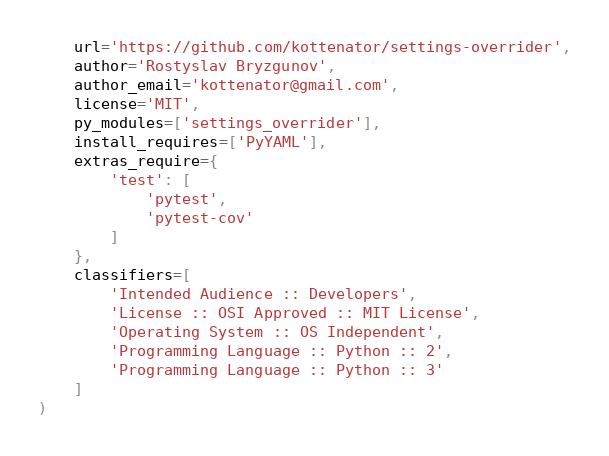Convert code to text. <code><loc_0><loc_0><loc_500><loc_500><_Python_>    url='https://github.com/kottenator/settings-overrider',
    author='Rostyslav Bryzgunov',
    author_email='kottenator@gmail.com',
    license='MIT',
    py_modules=['settings_overrider'],
    install_requires=['PyYAML'],
    extras_require={
        'test': [
            'pytest',
            'pytest-cov'
        ]
    },
    classifiers=[
        'Intended Audience :: Developers',
        'License :: OSI Approved :: MIT License',
        'Operating System :: OS Independent',
        'Programming Language :: Python :: 2',
        'Programming Language :: Python :: 3'
    ]
)
</code> 